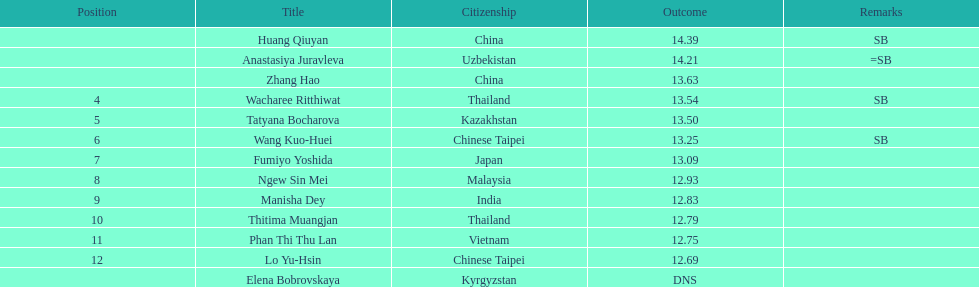How many people were ranked? 12. 